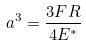Convert formula to latex. <formula><loc_0><loc_0><loc_500><loc_500>a ^ { 3 } = \frac { 3 F R } { 4 E ^ { * } }</formula> 